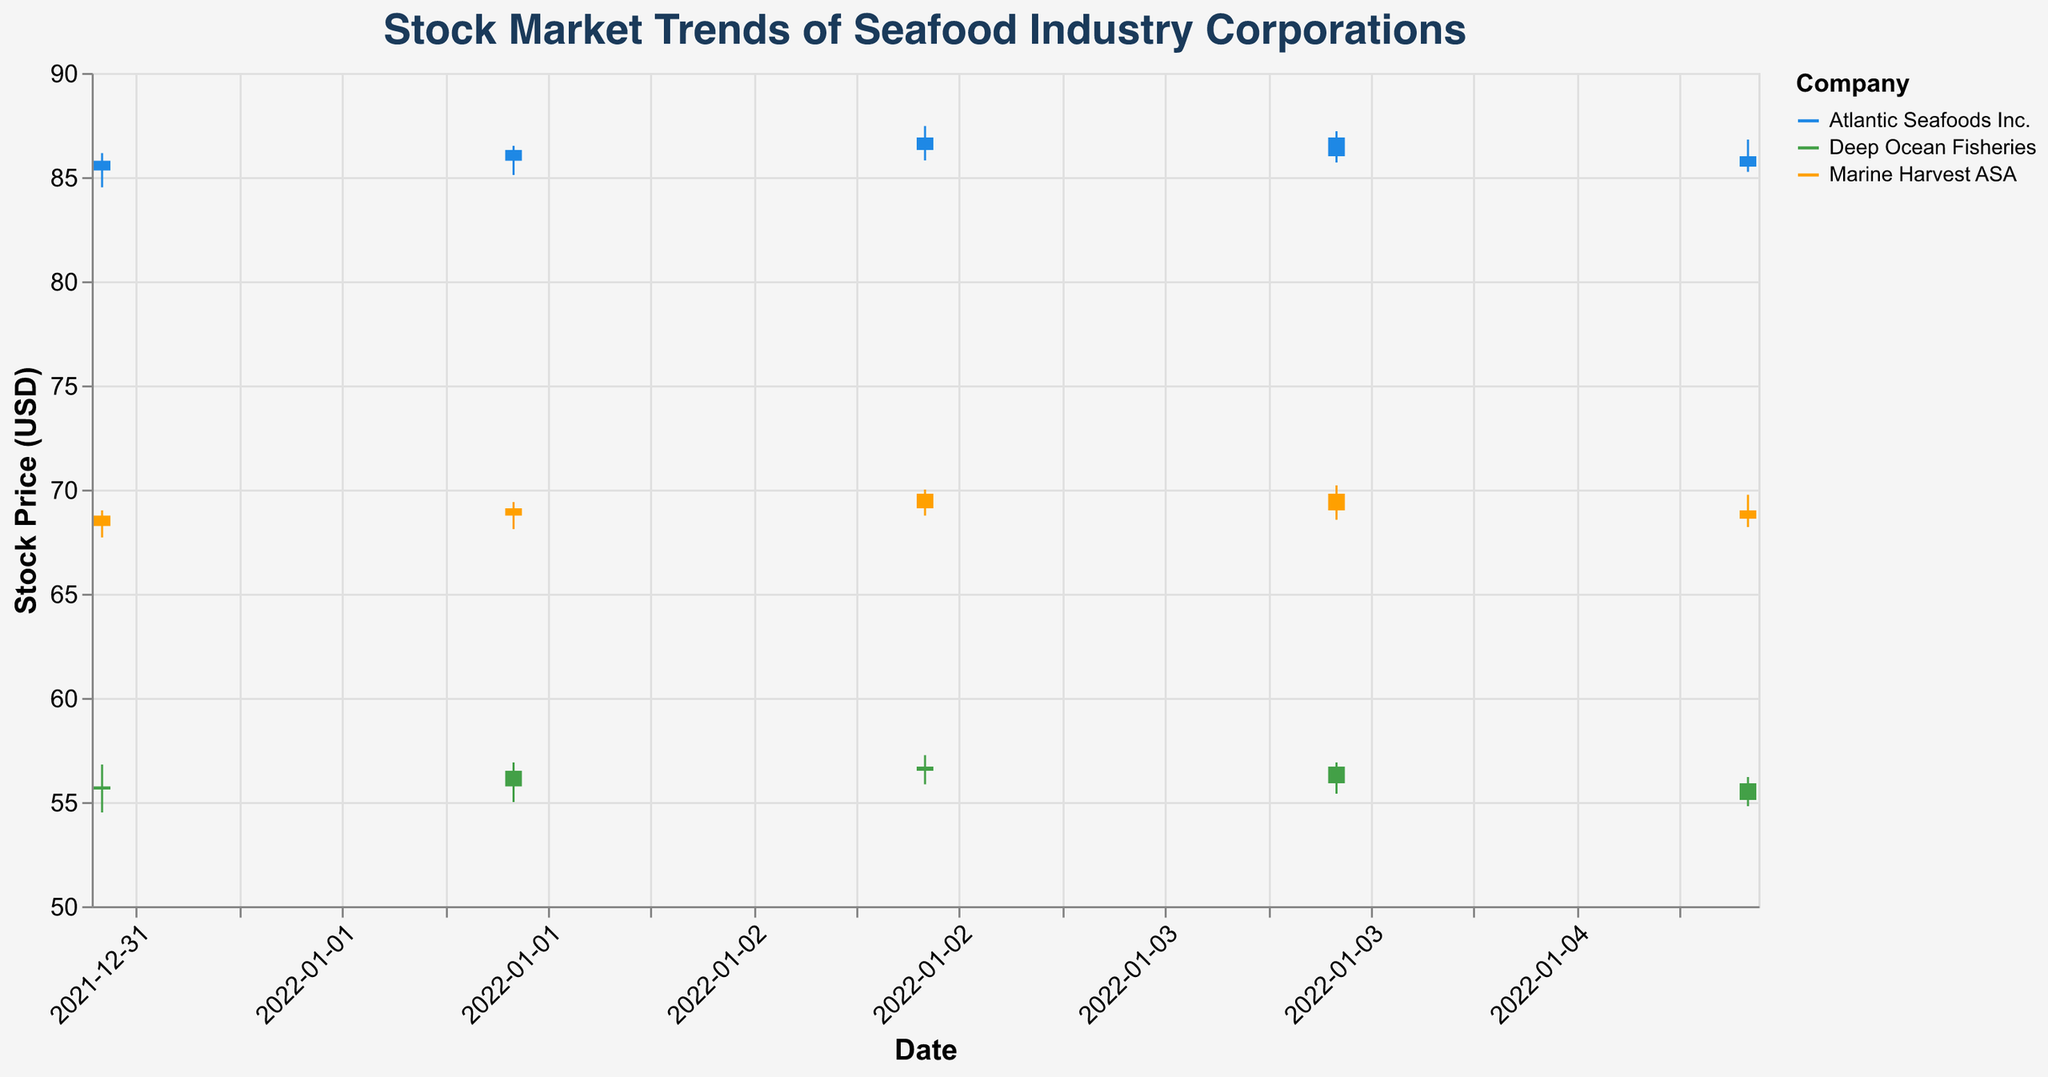What is the title of the figure? The title is displayed at the top of the figure and clearly reads "Stock Market Trends of Seafood Industry Corporations".
Answer: Stock Market Trends of Seafood Industry Corporations What are the three companies represented in the figure? The companies are represented by different colors in the chart and indicated in the legend: Atlantic Seafoods Inc., Deep Ocean Fisheries, and Marine Harvest ASA.
Answer: Atlantic Seafoods Inc., Deep Ocean Fisheries, Marine Harvest ASA Which company has the highest stock price on January 03, 2022? For January 03, 2022, we compare the 'High' values: Atlantic Seafoods Inc. (87.45), Deep Ocean Fisheries (57.25), and Marine Harvest ASA (70.00). The highest value is 87.45 from Atlantic Seafoods Inc.
Answer: Atlantic Seafoods Inc What is the difference between the closing prices of Atlantic Seafoods Inc. on January 01, 2022, and January 05, 2022? The closing price for Atlantic Seafoods Inc. on January 01, 2022, is 85.78, and on January 05, 2022, it is 85.50. The difference is 85.78 - 85.50 = 0.28.
Answer: 0.28 Compare the average closing prices of all three companies on January 01, 2022. Which company has the highest average closing price? Calculate the averages: Atlantic Seafoods Inc. (85.78), Deep Ocean Fisheries (55.75), Marine Harvest ASA (68.75). The highest value is for Atlantic Seafoods Inc.
Answer: Atlantic Seafoods Inc How did the stock price of Marine Harvest ASA change from January 03, 2022, to January 04, 2022? On January 03, the closing price was 69.80. On January 04, it closed at 69.00. The change is a decrease of 69.80 - 69.00 = 0.80.
Answer: Decreased by 0.80 Which company had the highest trading volume on January 02, 2022? On January 02, the volumes are: Atlantic Seafoods Inc. (140000), Deep Ocean Fisheries (195000), Marine Harvest ASA (165000). The highest volume is 195000 for Deep Ocean Fisheries.
Answer: Deep Ocean Fisheries Did the stock price of Deep Ocean Fisheries increase or decrease overall from January 01, 2022, to January 05, 2022? The closing price on January 01, 2022, was 55.75, and on January 05, 2022, it was 55.10. The stock price decreased overall by 55.75 - 55.10 = 0.65.
Answer: Decrease What is the range of stock prices for Atlantic Seafoods Inc. on January 04, 2022? The range of the stock prices is determined by subtracting the 'Low' from the 'High' on that date. For Atlantic Seafoods Inc. on January 04, 2022, the range is 87.20 - 85.70 = 1.50.
Answer: 1.50 